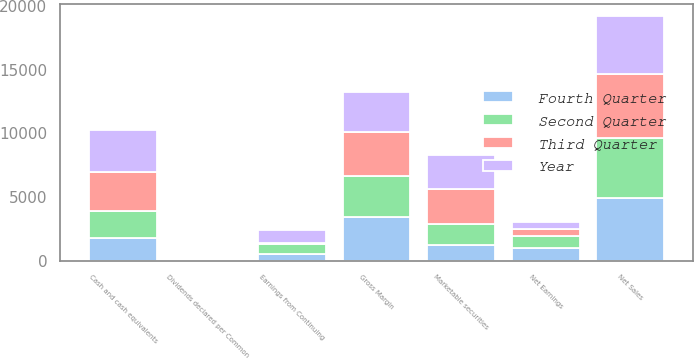Convert chart to OTSL. <chart><loc_0><loc_0><loc_500><loc_500><stacked_bar_chart><ecel><fcel>Net Sales<fcel>Gross Margin<fcel>Earnings from Continuing<fcel>Net Earnings<fcel>Dividends declared per Common<fcel>Cash and cash equivalents<fcel>Marketable securities<nl><fcel>Year<fcel>4532<fcel>3165<fcel>961<fcel>533<fcel>0.28<fcel>3311<fcel>2671<nl><fcel>Fourth Quarter<fcel>4889<fcel>3406<fcel>523<fcel>1004<fcel>0.28<fcel>1798<fcel>1242<nl><fcel>Second Quarter<fcel>4767<fcel>3284<fcel>755<fcel>964<fcel>0.28<fcel>2129<fcel>1652<nl><fcel>Third Quarter<fcel>5019<fcel>3424<fcel>139<fcel>499<fcel>0.28<fcel>3050<fcel>2749<nl></chart> 